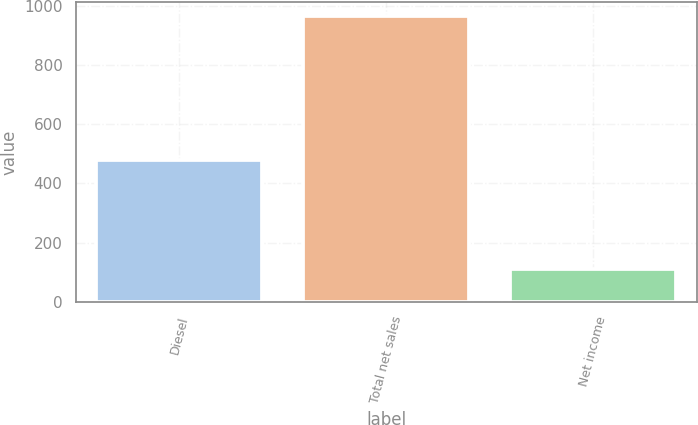Convert chart to OTSL. <chart><loc_0><loc_0><loc_500><loc_500><bar_chart><fcel>Diesel<fcel>Total net sales<fcel>Net income<nl><fcel>478<fcel>964<fcel>112<nl></chart> 